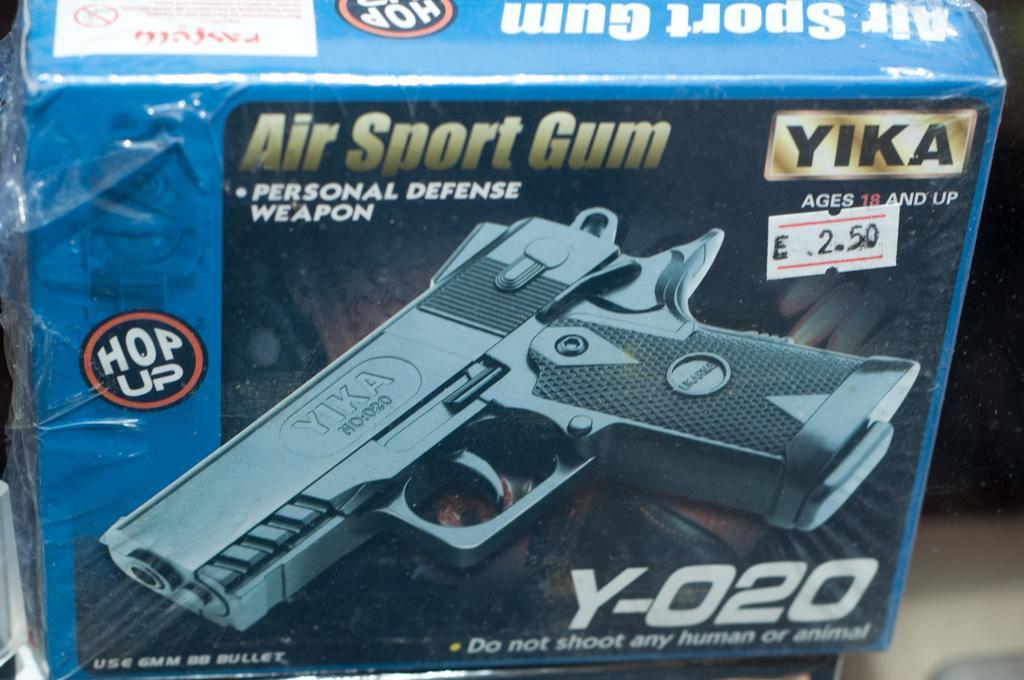Describe this image in one or two sentences. In this picture there is a box of personal defense weapon in the image. 